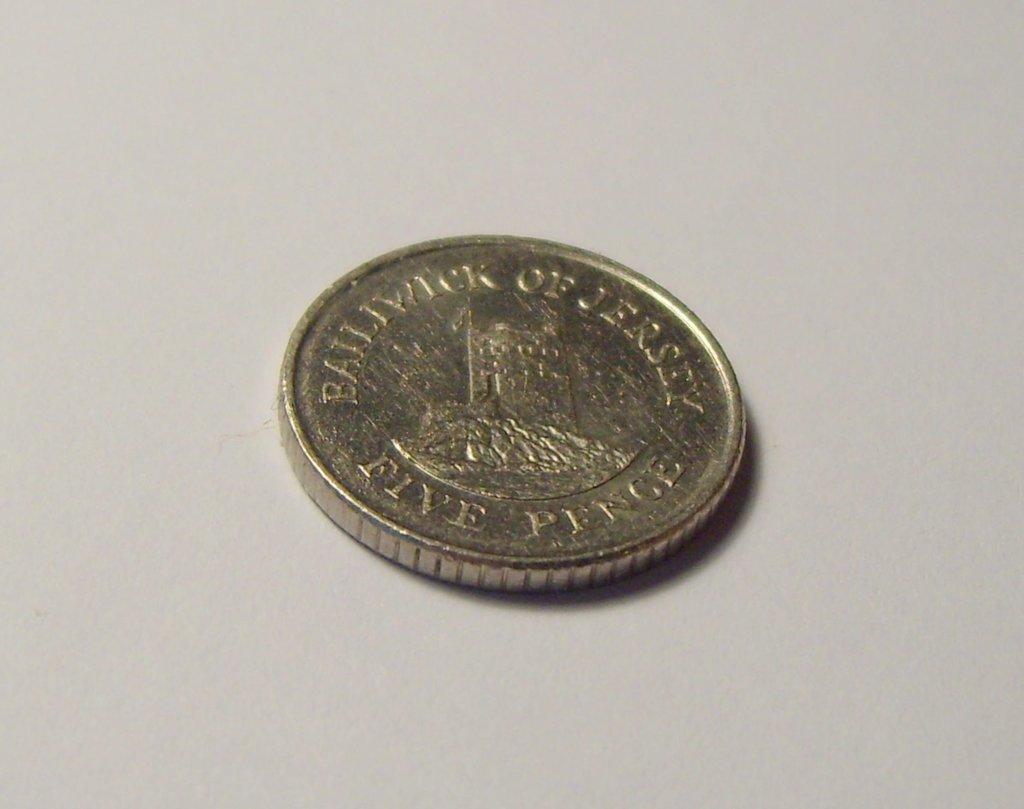Where is this coin from?
Offer a terse response. Bailiwick of jersey. What number is on the coin?
Keep it short and to the point. Five. 